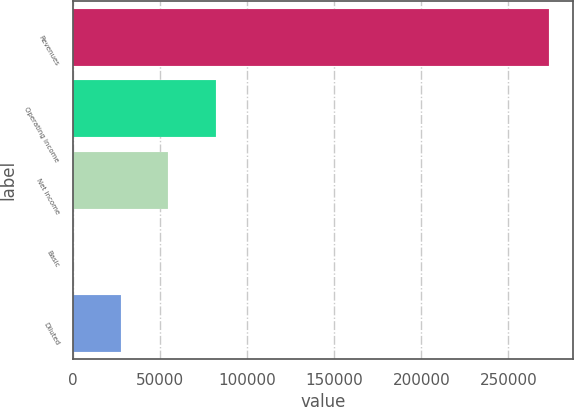Convert chart to OTSL. <chart><loc_0><loc_0><loc_500><loc_500><bar_chart><fcel>Revenues<fcel>Operating income<fcel>Net income<fcel>Basic<fcel>Diluted<nl><fcel>273533<fcel>82060.1<fcel>54706.8<fcel>0.21<fcel>27353.5<nl></chart> 